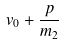<formula> <loc_0><loc_0><loc_500><loc_500>v _ { 0 } + \frac { p } { m _ { 2 } }</formula> 